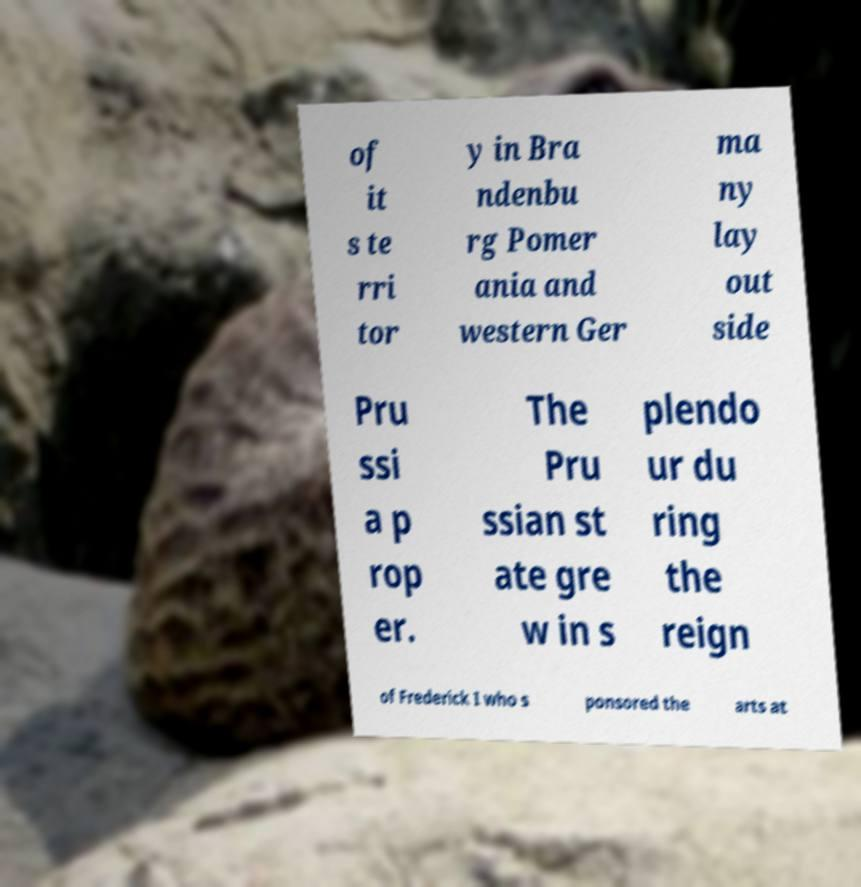There's text embedded in this image that I need extracted. Can you transcribe it verbatim? of it s te rri tor y in Bra ndenbu rg Pomer ania and western Ger ma ny lay out side Pru ssi a p rop er. The Pru ssian st ate gre w in s plendo ur du ring the reign of Frederick I who s ponsored the arts at 